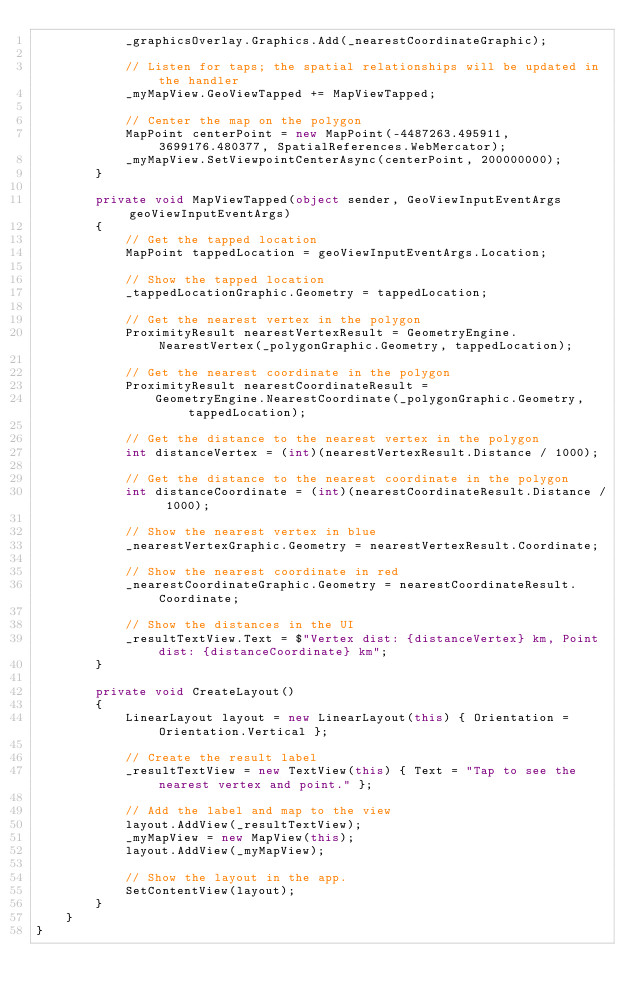Convert code to text. <code><loc_0><loc_0><loc_500><loc_500><_C#_>            _graphicsOverlay.Graphics.Add(_nearestCoordinateGraphic);

            // Listen for taps; the spatial relationships will be updated in the handler
            _myMapView.GeoViewTapped += MapViewTapped;

            // Center the map on the polygon
            MapPoint centerPoint = new MapPoint(-4487263.495911, 3699176.480377, SpatialReferences.WebMercator);
            _myMapView.SetViewpointCenterAsync(centerPoint, 200000000);
        }

        private void MapViewTapped(object sender, GeoViewInputEventArgs geoViewInputEventArgs)
        {
            // Get the tapped location
            MapPoint tappedLocation = geoViewInputEventArgs.Location;

            // Show the tapped location
            _tappedLocationGraphic.Geometry = tappedLocation;

            // Get the nearest vertex in the polygon
            ProximityResult nearestVertexResult = GeometryEngine.NearestVertex(_polygonGraphic.Geometry, tappedLocation);

            // Get the nearest coordinate in the polygon
            ProximityResult nearestCoordinateResult =
                GeometryEngine.NearestCoordinate(_polygonGraphic.Geometry, tappedLocation);

            // Get the distance to the nearest vertex in the polygon
            int distanceVertex = (int)(nearestVertexResult.Distance / 1000);

            // Get the distance to the nearest coordinate in the polygon
            int distanceCoordinate = (int)(nearestCoordinateResult.Distance / 1000);

            // Show the nearest vertex in blue
            _nearestVertexGraphic.Geometry = nearestVertexResult.Coordinate;

            // Show the nearest coordinate in red
            _nearestCoordinateGraphic.Geometry = nearestCoordinateResult.Coordinate;

            // Show the distances in the UI
            _resultTextView.Text = $"Vertex dist: {distanceVertex} km, Point dist: {distanceCoordinate} km";
        }

        private void CreateLayout()
        {
            LinearLayout layout = new LinearLayout(this) { Orientation = Orientation.Vertical };

            // Create the result label
            _resultTextView = new TextView(this) { Text = "Tap to see the nearest vertex and point." };

            // Add the label and map to the view
            layout.AddView(_resultTextView);
            _myMapView = new MapView(this);
            layout.AddView(_myMapView);

            // Show the layout in the app.
            SetContentView(layout);
        }
    }
}</code> 